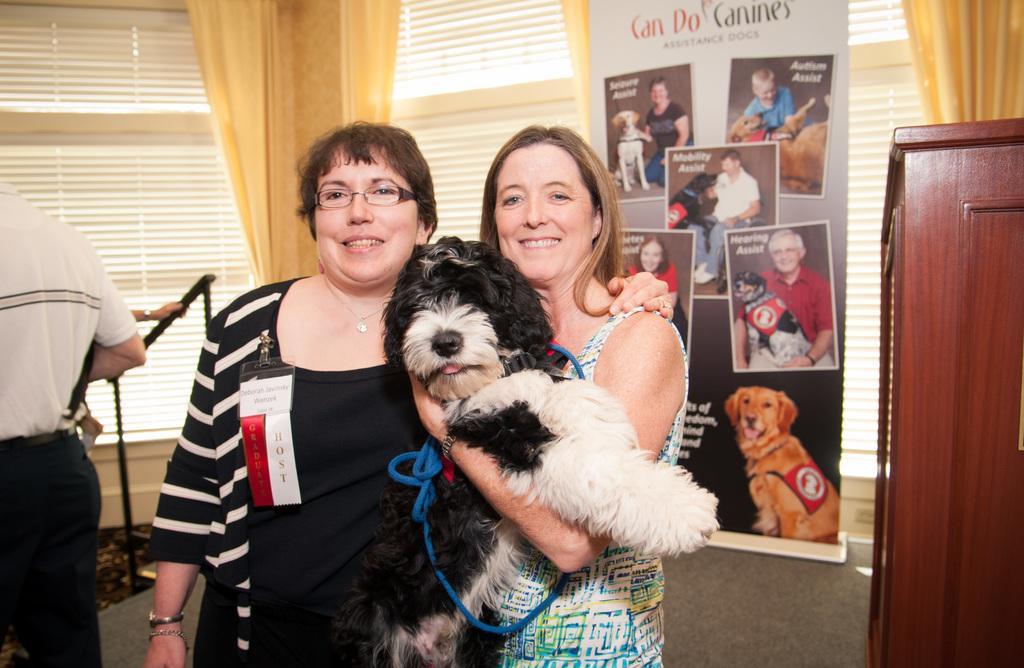Describe this image in one or two sentences. There are two ladies and the lady standing in the right is holding a dog in her hand and the lady standing in the left is placed one of her hand on beside lady and there is a person standing behind them. 